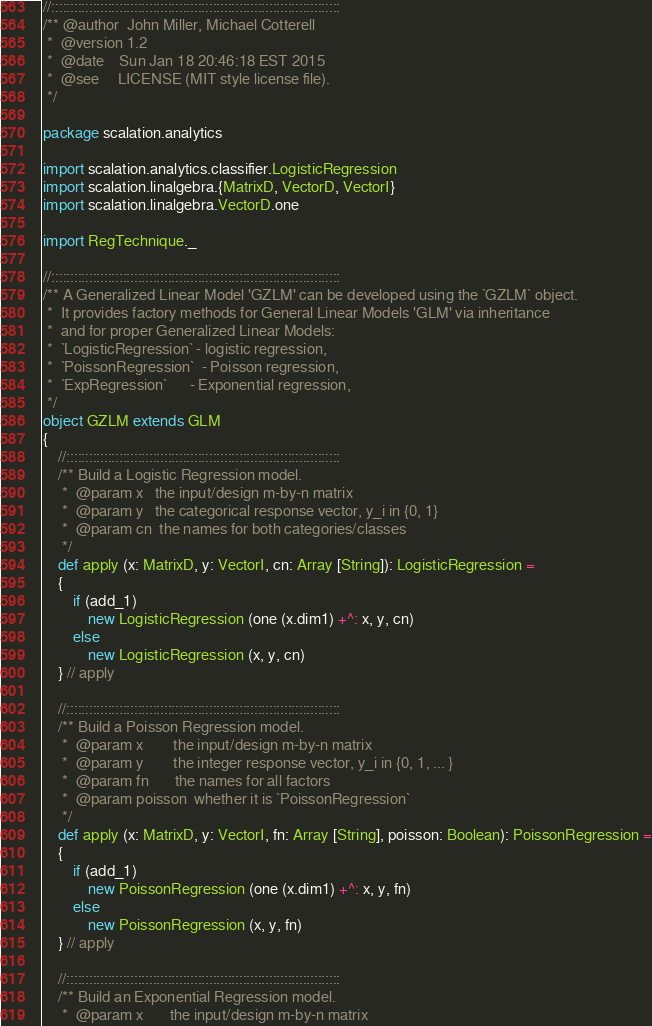Convert code to text. <code><loc_0><loc_0><loc_500><loc_500><_Scala_>
//:::::::::::::::::::::::::::::::::::::::::::::::::::::::::::::::::::::::::::::
/** @author  John Miller, Michael Cotterell
 *  @version 1.2
 *  @date    Sun Jan 18 20:46:18 EST 2015
 *  @see     LICENSE (MIT style license file).
 */

package scalation.analytics

import scalation.analytics.classifier.LogisticRegression
import scalation.linalgebra.{MatrixD, VectorD, VectorI}
import scalation.linalgebra.VectorD.one

import RegTechnique._

//:::::::::::::::::::::::::::::::::::::::::::::::::::::::::::::::::::::::::::::
/** A Generalized Linear Model 'GZLM' can be developed using the `GZLM` object.
 *  It provides factory methods for General Linear Models 'GLM' via inheritance
 *  and for proper Generalized Linear Models:
 *  `LogisticRegression` - logistic regression,
 *  `PoissonRegression`  - Poisson regression,
 *  `ExpRegression`      - Exponential regression,
 */
object GZLM extends GLM
{
    //:::::::::::::::::::::::::::::::::::::::::::::::::::::::::::::::::::::::::
    /** Build a Logistic Regression model.
     *  @param x   the input/design m-by-n matrix
     *  @param y   the categorical response vector, y_i in {0, 1}
     *  @param cn  the names for both categories/classes
     */
    def apply (x: MatrixD, y: VectorI, cn: Array [String]): LogisticRegression =
    {
        if (add_1)
            new LogisticRegression (one (x.dim1) +^: x, y, cn)
        else
            new LogisticRegression (x, y, cn)
    } // apply

    //:::::::::::::::::::::::::::::::::::::::::::::::::::::::::::::::::::::::::
    /** Build a Poisson Regression model.
     *  @param x        the input/design m-by-n matrix
     *  @param y        the integer response vector, y_i in {0, 1, ... }
     *  @param fn       the names for all factors
     *  @param poisson  whether it is `PoissonRegression`
     */
    def apply (x: MatrixD, y: VectorI, fn: Array [String], poisson: Boolean): PoissonRegression =
    {
        if (add_1)
            new PoissonRegression (one (x.dim1) +^: x, y, fn)
        else
            new PoissonRegression (x, y, fn)
    } // apply

    //:::::::::::::::::::::::::::::::::::::::::::::::::::::::::::::::::::::::::
    /** Build an Exponential Regression model.
     *  @param x       the input/design m-by-n matrix</code> 